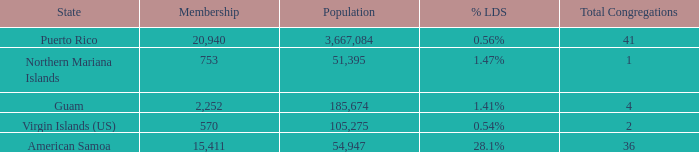What is Population, when Total Congregations is less than 4, and when % LDS is 0.54%? 105275.0. Can you give me this table as a dict? {'header': ['State', 'Membership', 'Population', '% LDS', 'Total Congregations'], 'rows': [['Puerto Rico', '20,940', '3,667,084', '0.56%', '41'], ['Northern Mariana Islands', '753', '51,395', '1.47%', '1'], ['Guam', '2,252', '185,674', '1.41%', '4'], ['Virgin Islands (US)', '570', '105,275', '0.54%', '2'], ['American Samoa', '15,411', '54,947', '28.1%', '36']]} 